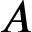Convert formula to latex. <formula><loc_0><loc_0><loc_500><loc_500>A</formula> 